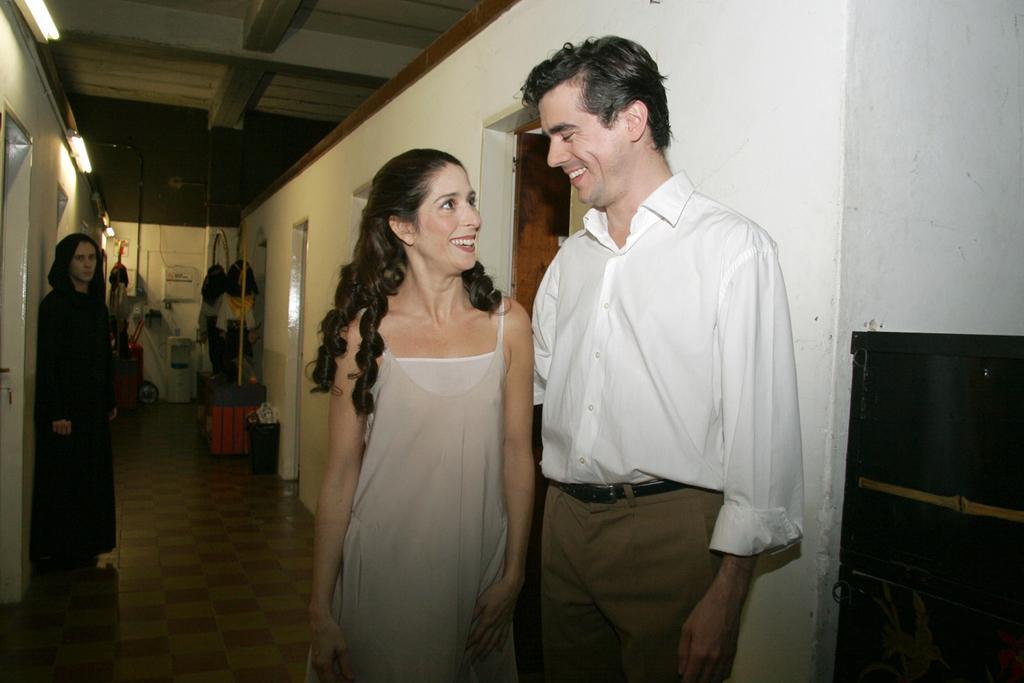Could you give a brief overview of what you see in this image? In this picture we can see few people, in the middle of the image we can see a man and woman, they both are smiling, in the background we can see few clothes and lights. 